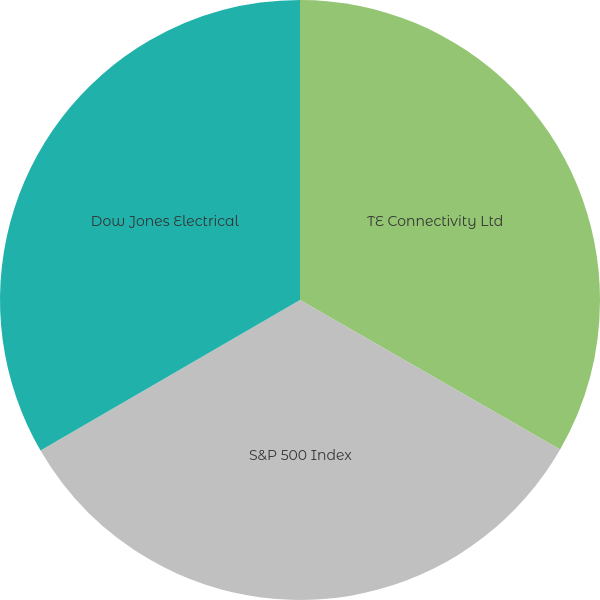<chart> <loc_0><loc_0><loc_500><loc_500><pie_chart><fcel>TE Connectivity Ltd<fcel>S&P 500 Index<fcel>Dow Jones Electrical<nl><fcel>33.3%<fcel>33.33%<fcel>33.37%<nl></chart> 